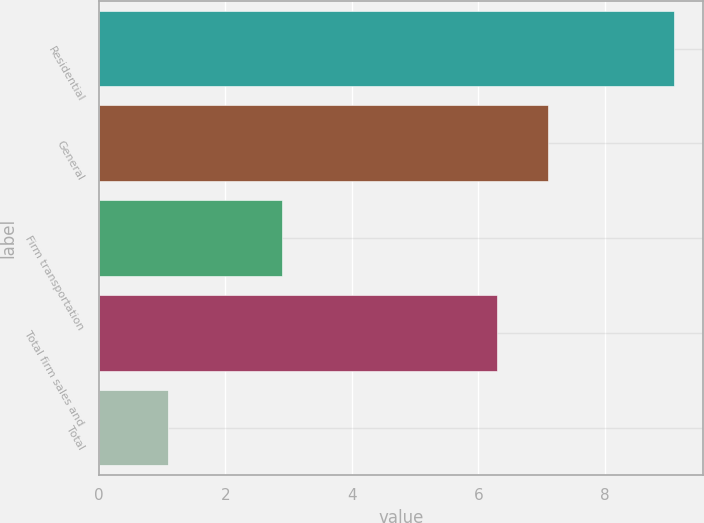Convert chart to OTSL. <chart><loc_0><loc_0><loc_500><loc_500><bar_chart><fcel>Residential<fcel>General<fcel>Firm transportation<fcel>Total firm sales and<fcel>Total<nl><fcel>9.1<fcel>7.1<fcel>2.9<fcel>6.3<fcel>1.1<nl></chart> 